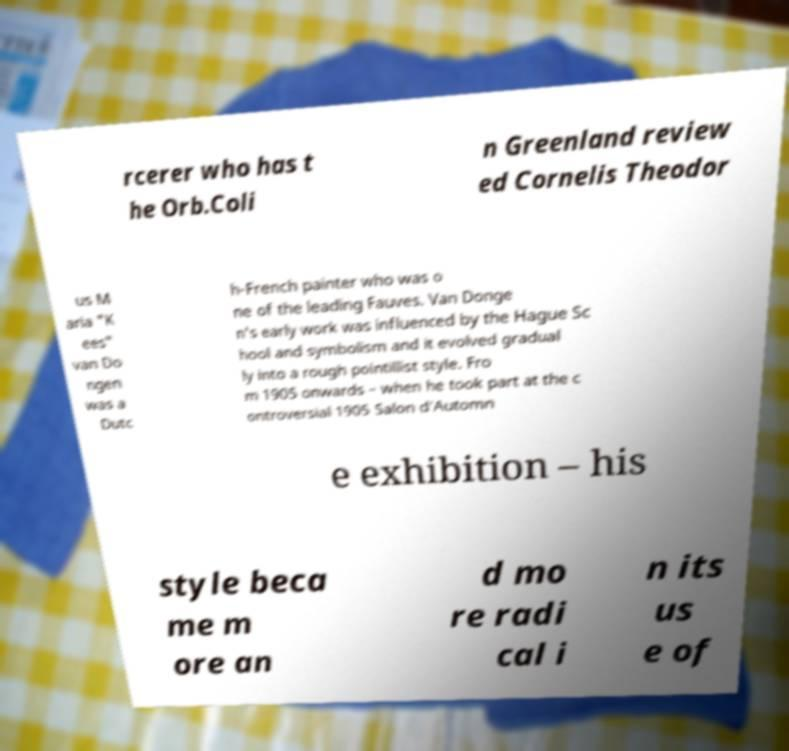I need the written content from this picture converted into text. Can you do that? rcerer who has t he Orb.Coli n Greenland review ed Cornelis Theodor us M aria "K ees" van Do ngen was a Dutc h-French painter who was o ne of the leading Fauves. Van Donge n's early work was influenced by the Hague Sc hool and symbolism and it evolved gradual ly into a rough pointillist style. Fro m 1905 onwards – when he took part at the c ontroversial 1905 Salon d'Automn e exhibition – his style beca me m ore an d mo re radi cal i n its us e of 